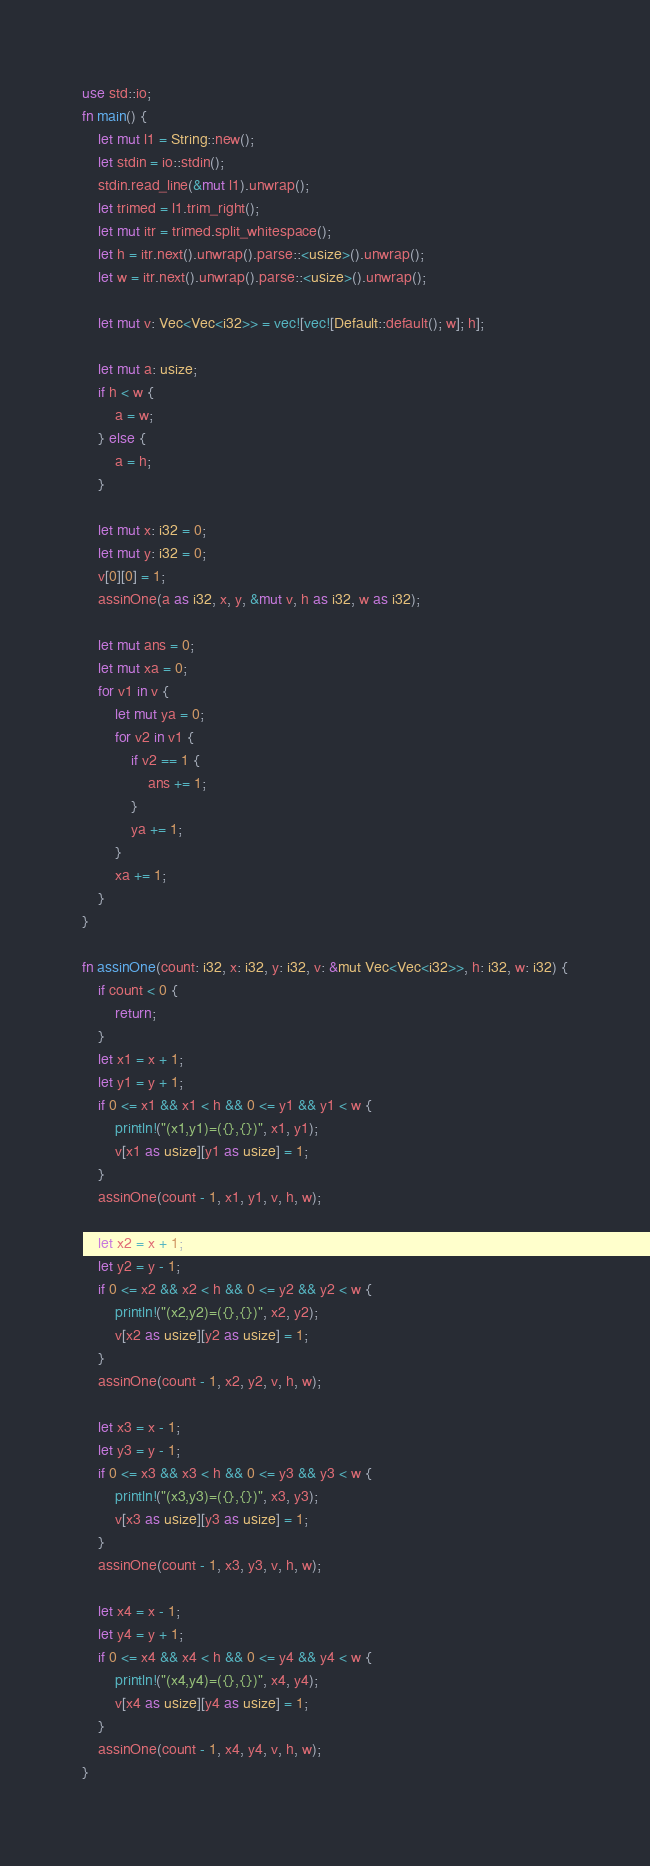Convert code to text. <code><loc_0><loc_0><loc_500><loc_500><_Rust_>use std::io;
fn main() {
    let mut l1 = String::new();
    let stdin = io::stdin();
    stdin.read_line(&mut l1).unwrap();
    let trimed = l1.trim_right();
    let mut itr = trimed.split_whitespace();
    let h = itr.next().unwrap().parse::<usize>().unwrap();
    let w = itr.next().unwrap().parse::<usize>().unwrap();

    let mut v: Vec<Vec<i32>> = vec![vec![Default::default(); w]; h];

    let mut a: usize;
    if h < w {
        a = w;
    } else {
        a = h;
    }

    let mut x: i32 = 0;
    let mut y: i32 = 0;
    v[0][0] = 1;
    assinOne(a as i32, x, y, &mut v, h as i32, w as i32);

    let mut ans = 0;
    let mut xa = 0;
    for v1 in v {
        let mut ya = 0;
        for v2 in v1 {
            if v2 == 1 {
                ans += 1;
            }
            ya += 1;
        }
        xa += 1;
    }
}

fn assinOne(count: i32, x: i32, y: i32, v: &mut Vec<Vec<i32>>, h: i32, w: i32) {
    if count < 0 {
        return;
    }
    let x1 = x + 1;
    let y1 = y + 1;
    if 0 <= x1 && x1 < h && 0 <= y1 && y1 < w {
        println!("(x1,y1)=({},{})", x1, y1);
        v[x1 as usize][y1 as usize] = 1;
    }
    assinOne(count - 1, x1, y1, v, h, w);

    let x2 = x + 1;
    let y2 = y - 1;
    if 0 <= x2 && x2 < h && 0 <= y2 && y2 < w {
        println!("(x2,y2)=({},{})", x2, y2);
        v[x2 as usize][y2 as usize] = 1;
    }
    assinOne(count - 1, x2, y2, v, h, w);

    let x3 = x - 1;
    let y3 = y - 1;
    if 0 <= x3 && x3 < h && 0 <= y3 && y3 < w {
        println!("(x3,y3)=({},{})", x3, y3);
        v[x3 as usize][y3 as usize] = 1;
    }
    assinOne(count - 1, x3, y3, v, h, w);

    let x4 = x - 1;
    let y4 = y + 1;
    if 0 <= x4 && x4 < h && 0 <= y4 && y4 < w {
        println!("(x4,y4)=({},{})", x4, y4);
        v[x4 as usize][y4 as usize] = 1;
    }
    assinOne(count - 1, x4, y4, v, h, w);
}
</code> 